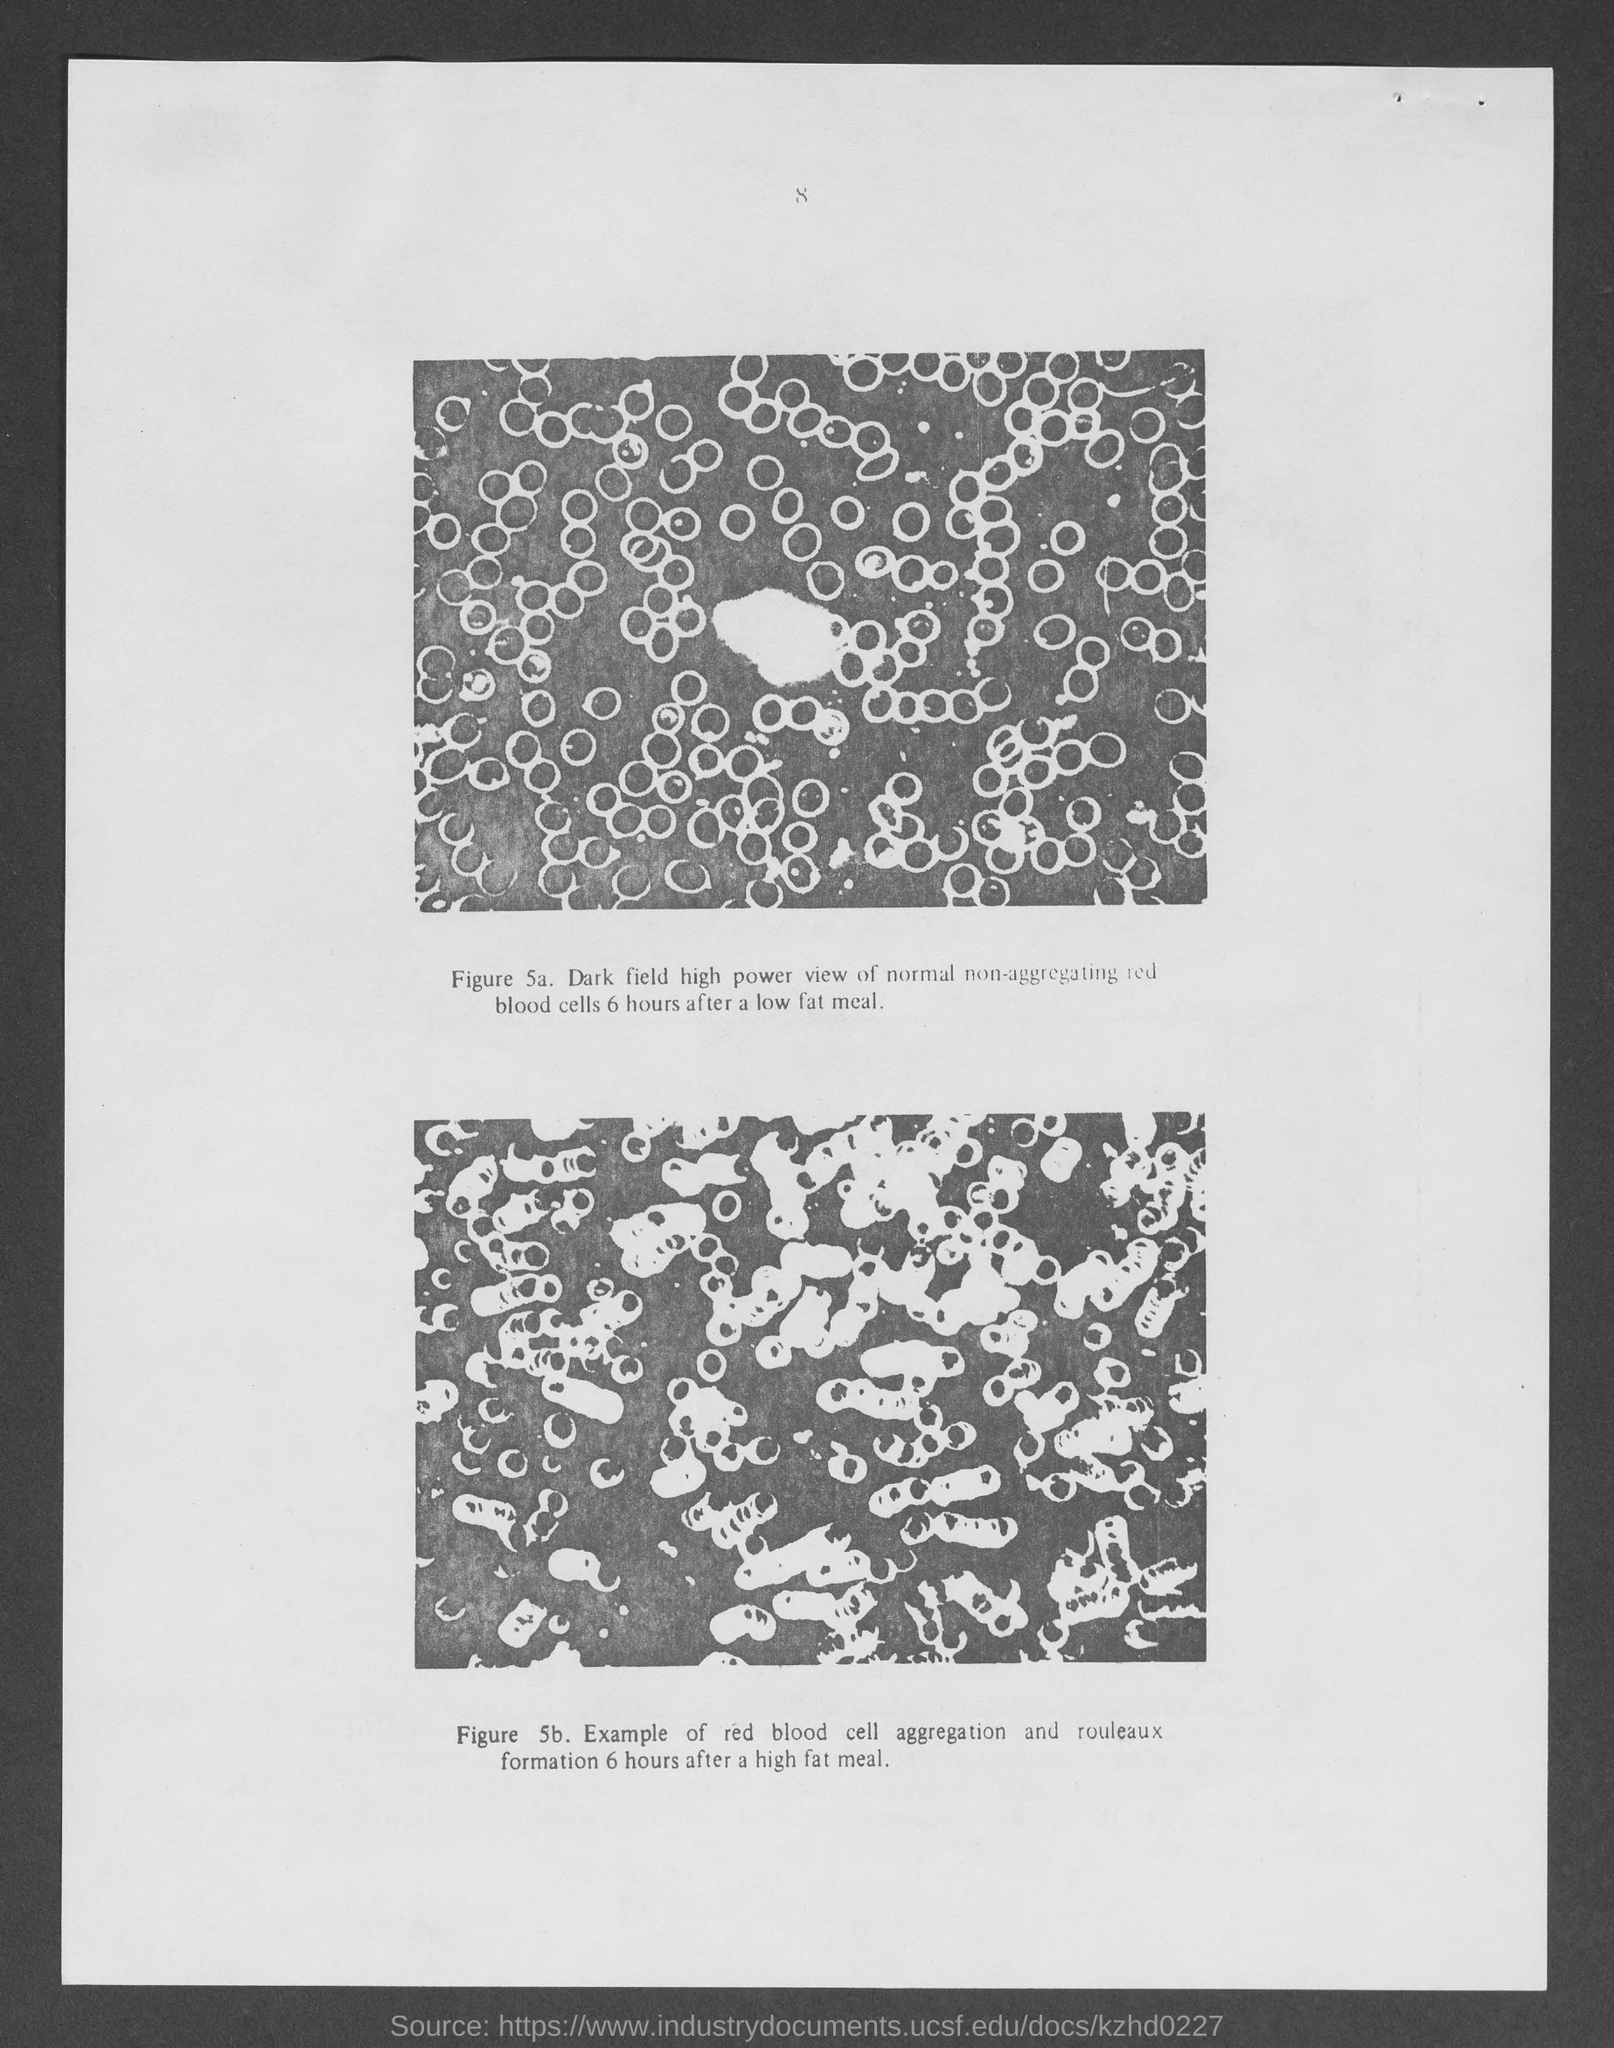Give some essential details in this illustration. I am looking at a page with a number at the top that is 8.. 